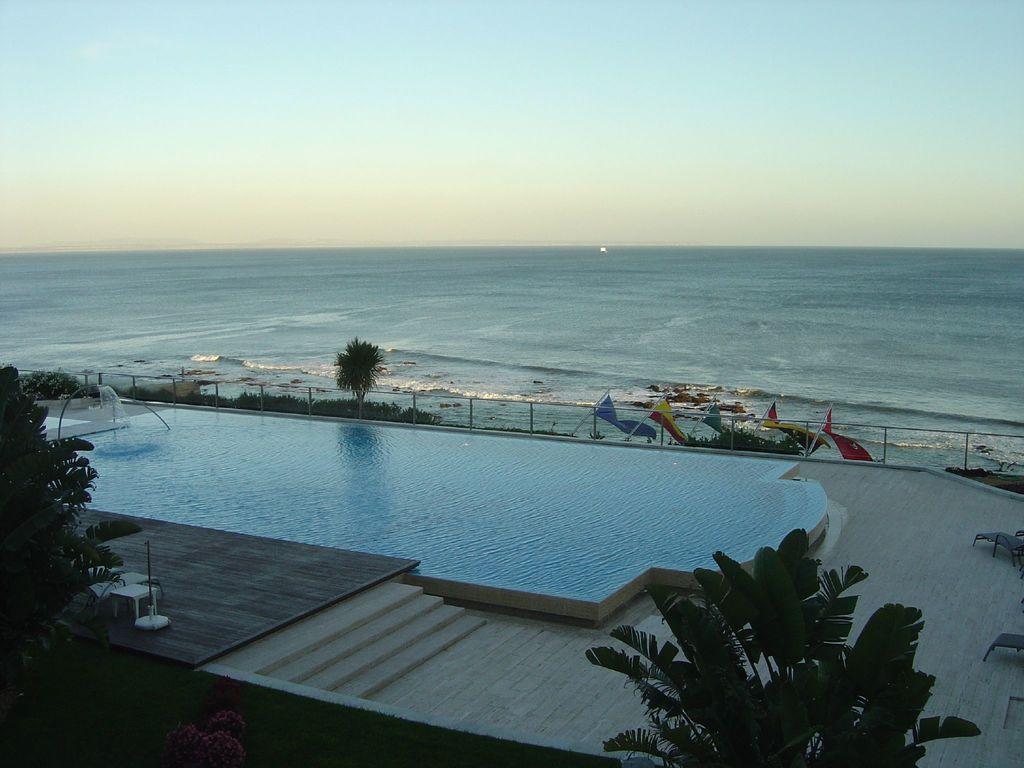In one or two sentences, can you explain what this image depicts? In the center of the image we can see the sky, water, trees, flags, fence, swimming pool and a few other objects. 